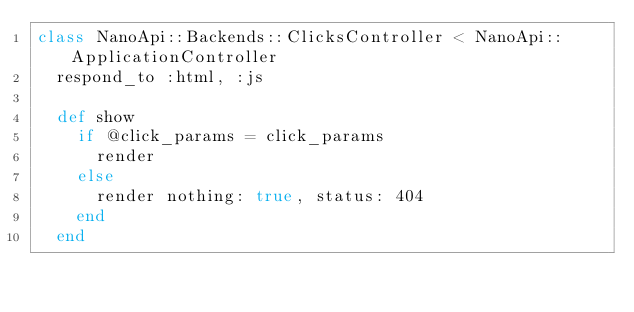<code> <loc_0><loc_0><loc_500><loc_500><_Ruby_>class NanoApi::Backends::ClicksController < NanoApi::ApplicationController
  respond_to :html, :js

  def show
    if @click_params = click_params
      render
    else
      render nothing: true, status: 404
    end
  end
</code> 